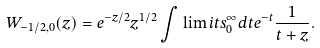<formula> <loc_0><loc_0><loc_500><loc_500>W _ { - 1 / 2 , 0 } ( z ) = e ^ { - z / 2 } z ^ { 1 / 2 } \int \lim i t s _ { 0 } ^ { \infty } { d t e ^ { - t } \frac { 1 } { t + z } } .</formula> 